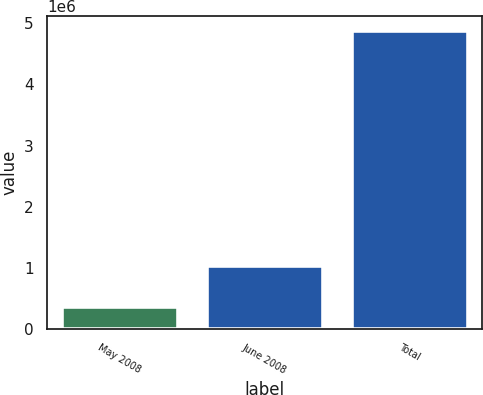Convert chart. <chart><loc_0><loc_0><loc_500><loc_500><bar_chart><fcel>May 2008<fcel>June 2008<fcel>Total<nl><fcel>354600<fcel>1.0285e+06<fcel>4.87562e+06<nl></chart> 